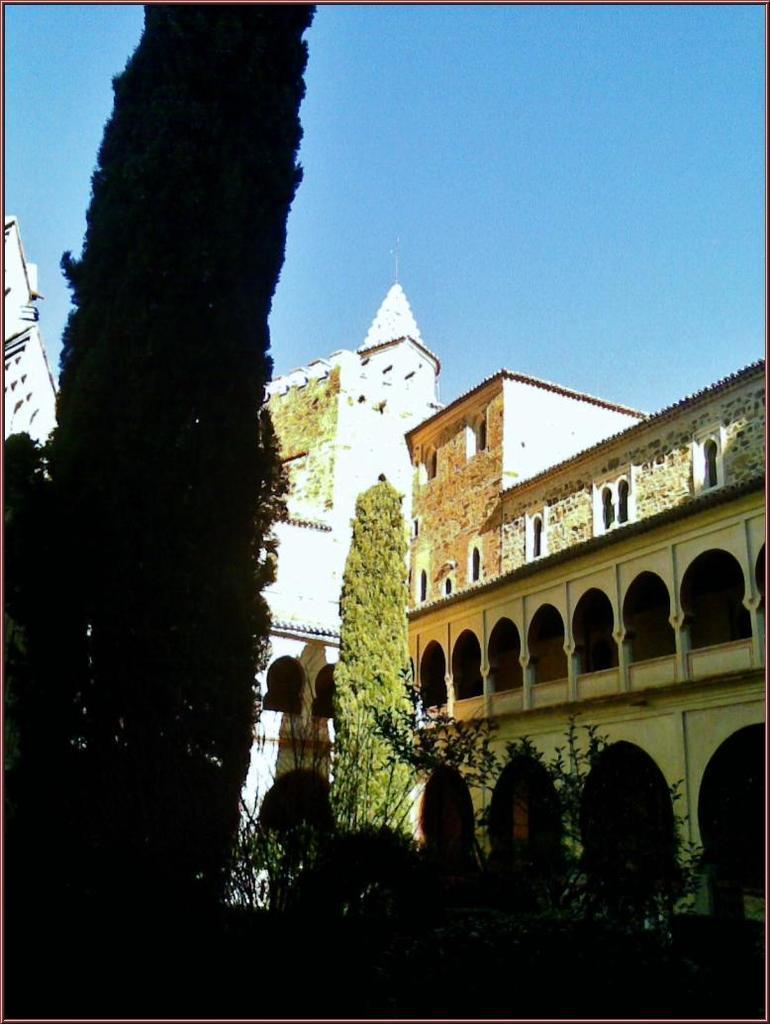Can you describe this image briefly? In this image we can see trees, plants, buildings and the sky. 